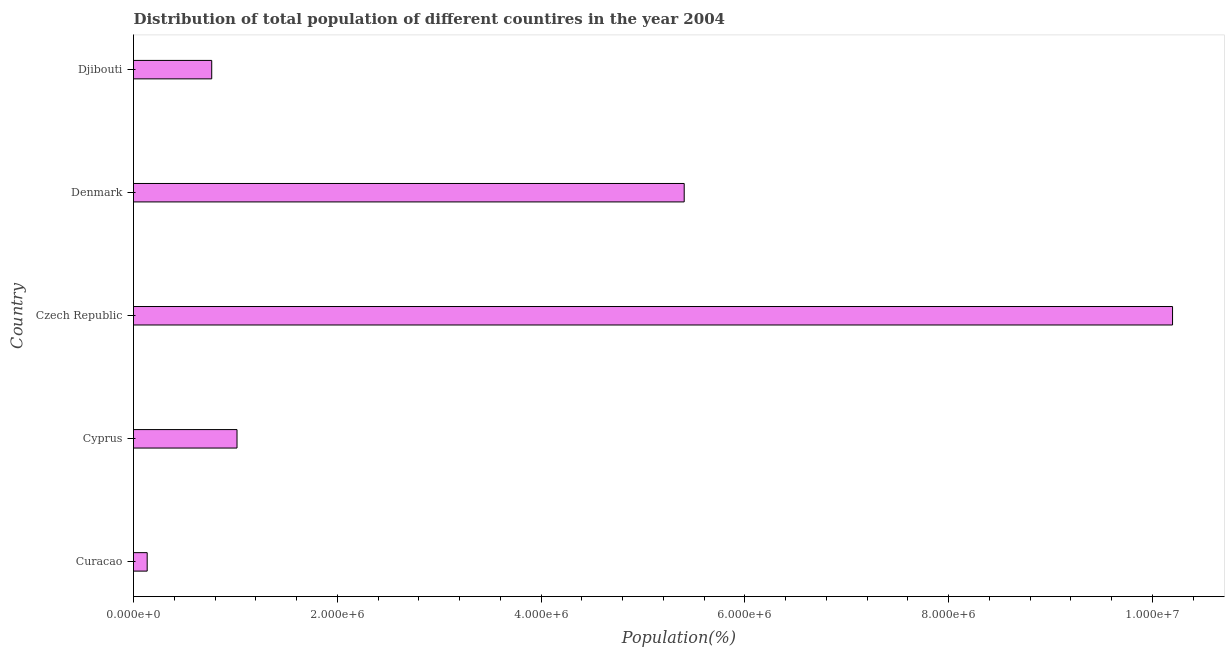What is the title of the graph?
Provide a short and direct response. Distribution of total population of different countires in the year 2004. What is the label or title of the X-axis?
Your answer should be very brief. Population(%). What is the label or title of the Y-axis?
Your answer should be very brief. Country. What is the population in Czech Republic?
Give a very brief answer. 1.02e+07. Across all countries, what is the maximum population?
Provide a short and direct response. 1.02e+07. Across all countries, what is the minimum population?
Ensure brevity in your answer.  1.34e+05. In which country was the population maximum?
Offer a terse response. Czech Republic. In which country was the population minimum?
Give a very brief answer. Curacao. What is the sum of the population?
Ensure brevity in your answer.  1.75e+07. What is the difference between the population in Cyprus and Czech Republic?
Your response must be concise. -9.18e+06. What is the average population per country?
Your response must be concise. 3.50e+06. What is the median population?
Give a very brief answer. 1.02e+06. In how many countries, is the population greater than 6400000 %?
Your answer should be compact. 1. What is the ratio of the population in Curacao to that in Djibouti?
Offer a very short reply. 0.17. Is the population in Cyprus less than that in Denmark?
Make the answer very short. Yes. What is the difference between the highest and the second highest population?
Keep it short and to the point. 4.79e+06. What is the difference between the highest and the lowest population?
Your response must be concise. 1.01e+07. Are all the bars in the graph horizontal?
Give a very brief answer. Yes. How many countries are there in the graph?
Make the answer very short. 5. What is the difference between two consecutive major ticks on the X-axis?
Offer a terse response. 2.00e+06. Are the values on the major ticks of X-axis written in scientific E-notation?
Offer a terse response. Yes. What is the Population(%) in Curacao?
Offer a terse response. 1.34e+05. What is the Population(%) of Cyprus?
Your response must be concise. 1.02e+06. What is the Population(%) in Czech Republic?
Your response must be concise. 1.02e+07. What is the Population(%) in Denmark?
Your response must be concise. 5.40e+06. What is the Population(%) in Djibouti?
Your response must be concise. 7.68e+05. What is the difference between the Population(%) in Curacao and Cyprus?
Offer a very short reply. -8.82e+05. What is the difference between the Population(%) in Curacao and Czech Republic?
Provide a succinct answer. -1.01e+07. What is the difference between the Population(%) in Curacao and Denmark?
Provide a short and direct response. -5.27e+06. What is the difference between the Population(%) in Curacao and Djibouti?
Your answer should be compact. -6.33e+05. What is the difference between the Population(%) in Cyprus and Czech Republic?
Your answer should be very brief. -9.18e+06. What is the difference between the Population(%) in Cyprus and Denmark?
Your response must be concise. -4.39e+06. What is the difference between the Population(%) in Cyprus and Djibouti?
Offer a very short reply. 2.48e+05. What is the difference between the Population(%) in Czech Republic and Denmark?
Give a very brief answer. 4.79e+06. What is the difference between the Population(%) in Czech Republic and Djibouti?
Give a very brief answer. 9.43e+06. What is the difference between the Population(%) in Denmark and Djibouti?
Offer a terse response. 4.64e+06. What is the ratio of the Population(%) in Curacao to that in Cyprus?
Give a very brief answer. 0.13. What is the ratio of the Population(%) in Curacao to that in Czech Republic?
Make the answer very short. 0.01. What is the ratio of the Population(%) in Curacao to that in Denmark?
Your response must be concise. 0.03. What is the ratio of the Population(%) in Curacao to that in Djibouti?
Provide a short and direct response. 0.17. What is the ratio of the Population(%) in Cyprus to that in Czech Republic?
Provide a succinct answer. 0.1. What is the ratio of the Population(%) in Cyprus to that in Denmark?
Give a very brief answer. 0.19. What is the ratio of the Population(%) in Cyprus to that in Djibouti?
Offer a very short reply. 1.32. What is the ratio of the Population(%) in Czech Republic to that in Denmark?
Offer a very short reply. 1.89. What is the ratio of the Population(%) in Czech Republic to that in Djibouti?
Your answer should be very brief. 13.28. What is the ratio of the Population(%) in Denmark to that in Djibouti?
Offer a terse response. 7.04. 